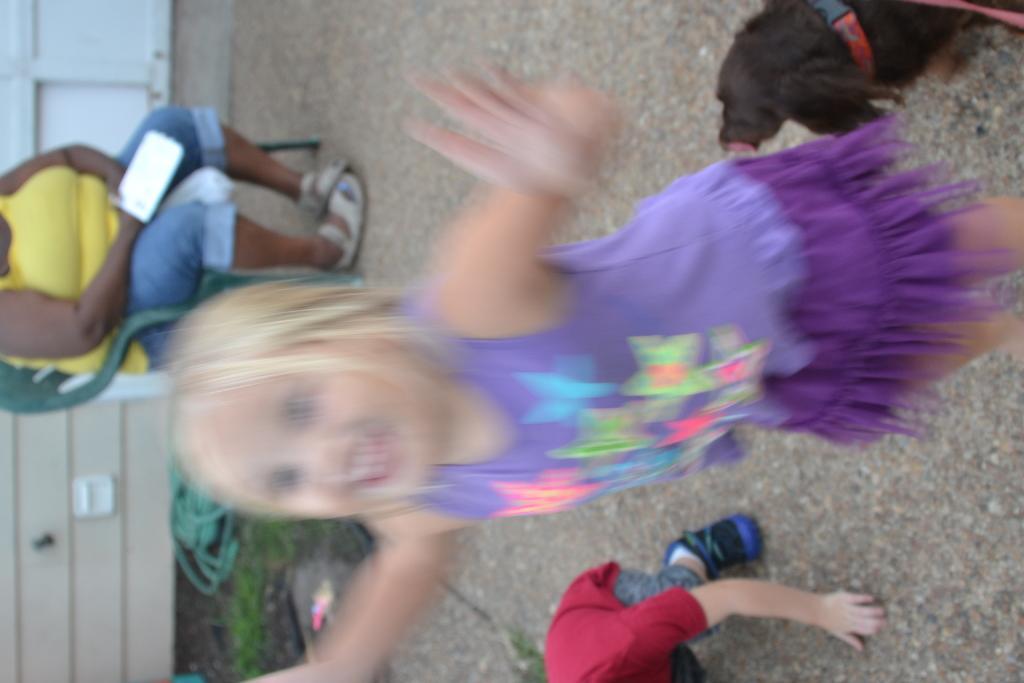In one or two sentences, can you explain what this image depicts? I see that this image is a bit blurry and I see 2 children over here, a dog which is of black in color and I see a woman who is sitting on this chair and I see the path. 